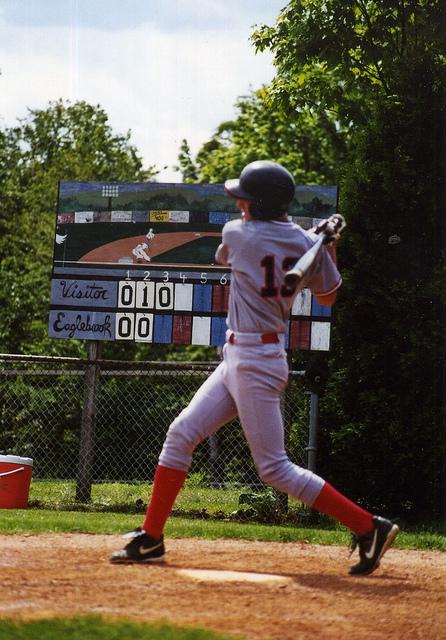What is the score?
Answer briefly. 1-0. What are the score?
Write a very short answer. 1 to 0. How many posts does the sign have?
Concise answer only. 2. Are is pants dirty?
Write a very short answer. No. What brand are the player's sneakers?
Concise answer only. Nike. What color is the hat?
Write a very short answer. Black. 